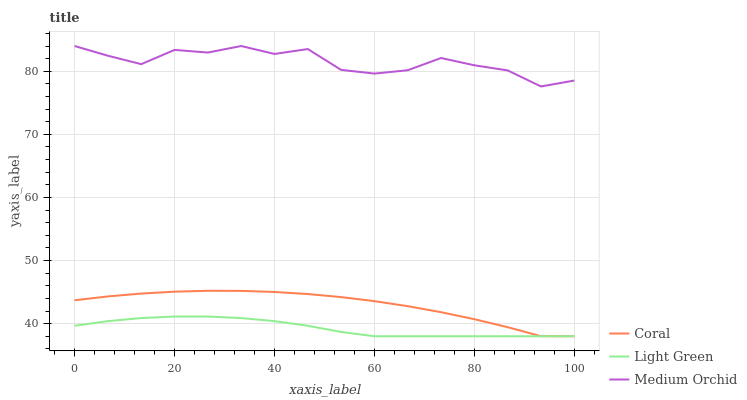Does Medium Orchid have the minimum area under the curve?
Answer yes or no. No. Does Light Green have the maximum area under the curve?
Answer yes or no. No. Is Medium Orchid the smoothest?
Answer yes or no. No. Is Light Green the roughest?
Answer yes or no. No. Does Medium Orchid have the lowest value?
Answer yes or no. No. Does Light Green have the highest value?
Answer yes or no. No. Is Light Green less than Medium Orchid?
Answer yes or no. Yes. Is Medium Orchid greater than Coral?
Answer yes or no. Yes. Does Light Green intersect Medium Orchid?
Answer yes or no. No. 